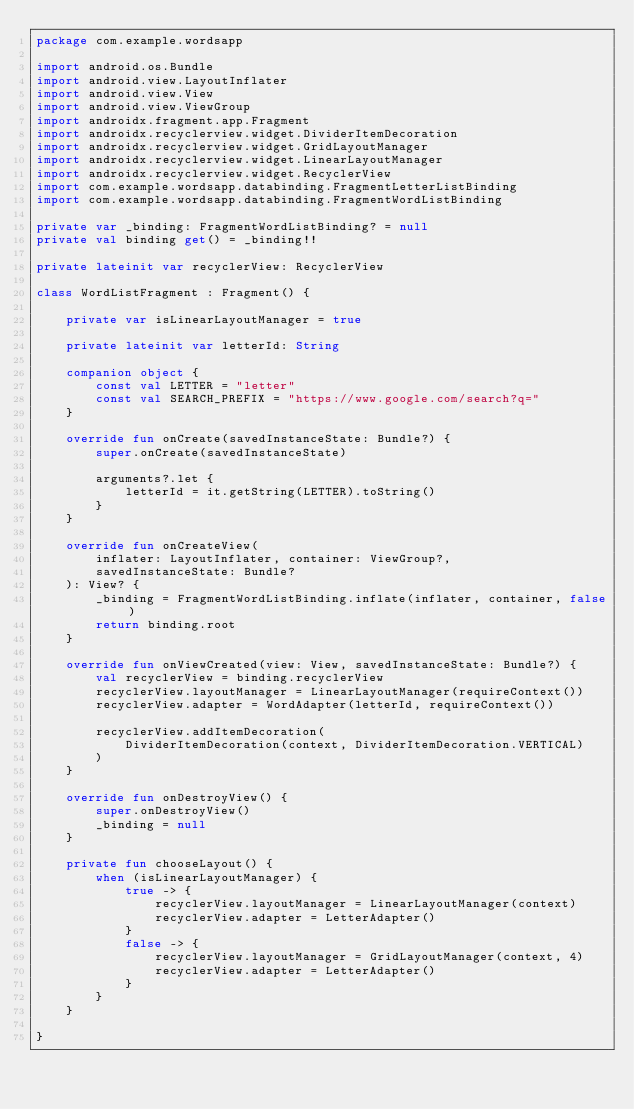<code> <loc_0><loc_0><loc_500><loc_500><_Kotlin_>package com.example.wordsapp

import android.os.Bundle
import android.view.LayoutInflater
import android.view.View
import android.view.ViewGroup
import androidx.fragment.app.Fragment
import androidx.recyclerview.widget.DividerItemDecoration
import androidx.recyclerview.widget.GridLayoutManager
import androidx.recyclerview.widget.LinearLayoutManager
import androidx.recyclerview.widget.RecyclerView
import com.example.wordsapp.databinding.FragmentLetterListBinding
import com.example.wordsapp.databinding.FragmentWordListBinding

private var _binding: FragmentWordListBinding? = null
private val binding get() = _binding!!

private lateinit var recyclerView: RecyclerView

class WordListFragment : Fragment() {

    private var isLinearLayoutManager = true

    private lateinit var letterId: String

    companion object {
        const val LETTER = "letter"
        const val SEARCH_PREFIX = "https://www.google.com/search?q="
    }

    override fun onCreate(savedInstanceState: Bundle?) {
        super.onCreate(savedInstanceState)

        arguments?.let {
            letterId = it.getString(LETTER).toString()
        }
    }

    override fun onCreateView(
        inflater: LayoutInflater, container: ViewGroup?,
        savedInstanceState: Bundle?
    ): View? {
        _binding = FragmentWordListBinding.inflate(inflater, container, false)
        return binding.root
    }

    override fun onViewCreated(view: View, savedInstanceState: Bundle?) {
        val recyclerView = binding.recyclerView
        recyclerView.layoutManager = LinearLayoutManager(requireContext())
        recyclerView.adapter = WordAdapter(letterId, requireContext())

        recyclerView.addItemDecoration(
            DividerItemDecoration(context, DividerItemDecoration.VERTICAL)
        )
    }

    override fun onDestroyView() {
        super.onDestroyView()
        _binding = null
    }

    private fun chooseLayout() {
        when (isLinearLayoutManager) {
            true -> {
                recyclerView.layoutManager = LinearLayoutManager(context)
                recyclerView.adapter = LetterAdapter()
            }
            false -> {
                recyclerView.layoutManager = GridLayoutManager(context, 4)
                recyclerView.adapter = LetterAdapter()
            }
        }
    }

}</code> 